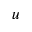<formula> <loc_0><loc_0><loc_500><loc_500>\boldsymbol u</formula> 